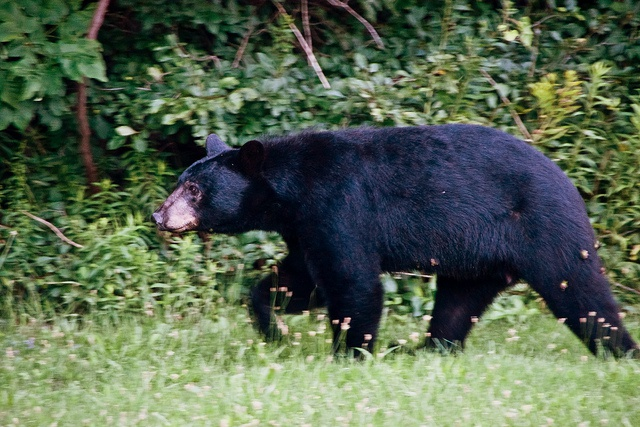Describe the objects in this image and their specific colors. I can see a bear in darkgreen, black, navy, and gray tones in this image. 